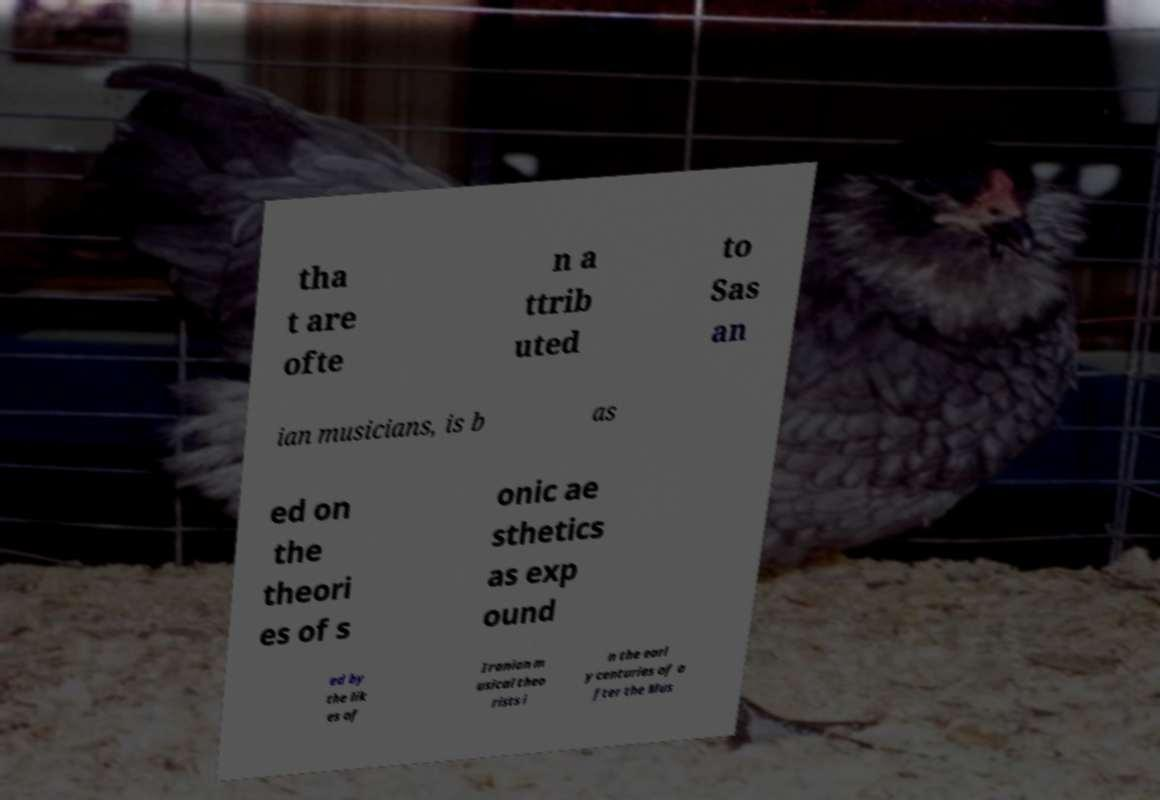Could you assist in decoding the text presented in this image and type it out clearly? tha t are ofte n a ttrib uted to Sas an ian musicians, is b as ed on the theori es of s onic ae sthetics as exp ound ed by the lik es of Iranian m usical theo rists i n the earl y centuries of a fter the Mus 